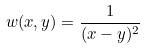Convert formula to latex. <formula><loc_0><loc_0><loc_500><loc_500>w ( x , y ) = \frac { 1 } { ( x - y ) ^ { 2 } }</formula> 